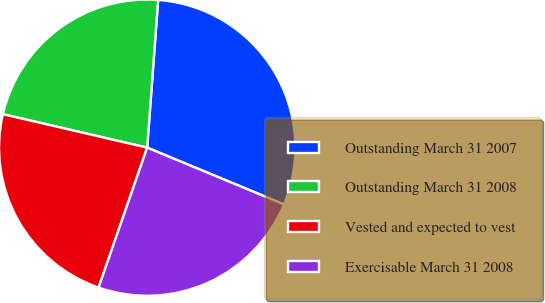Convert chart to OTSL. <chart><loc_0><loc_0><loc_500><loc_500><pie_chart><fcel>Outstanding March 31 2007<fcel>Outstanding March 31 2008<fcel>Vested and expected to vest<fcel>Exercisable March 31 2008<nl><fcel>30.08%<fcel>22.56%<fcel>23.31%<fcel>24.06%<nl></chart> 